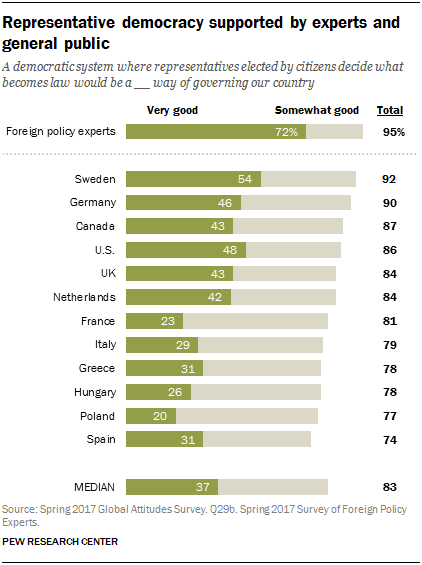Outline some significant characteristics in this image. The median reveals that there is a ratio of 1.57 between those who consider themselves to be very good and those who consider themselves to be somewhat good. In Canada, the very good percentage is 43 percent. 